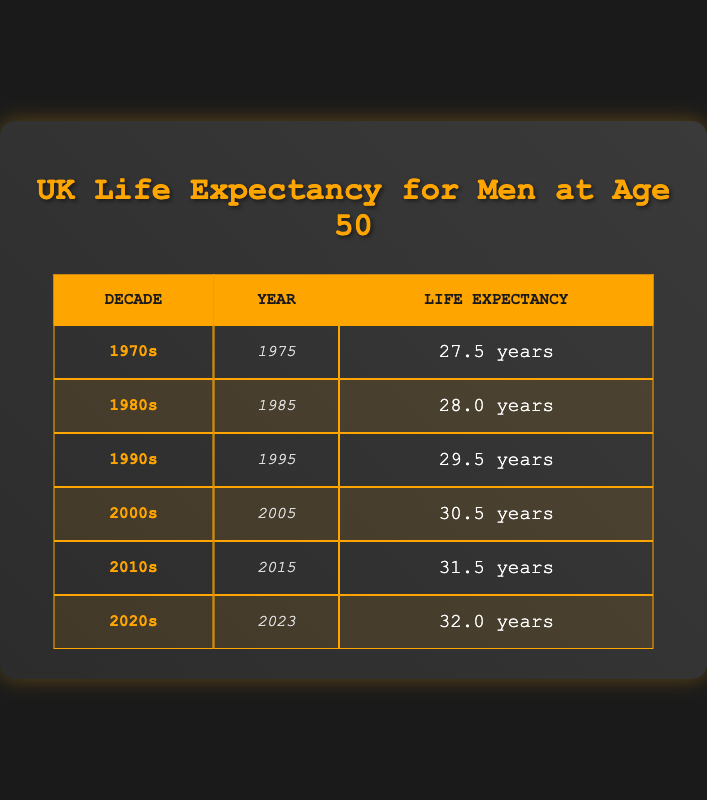What was the life expectancy at age 50 for men in the 1980s? The table indicates that in the 1980s, the life expectancy for men at age 50 was listed alongside the year 1985. This value is explicitly provided as 28.0 years.
Answer: 28.0 years Which decade had the lowest life expectancy for men at age 50? By reviewing the life expectancy values provided in the table, the 1970s show the lowest figure at 27.5 years, compared to other decades listed.
Answer: 1970s What is the difference in life expectancy at age 50 for men between the 1990s and the 2000s? To find the difference, we subtract the life expectancy of the 1990s (29.5 years) from the 2000s (30.5 years). The calculation shows a difference of 1.0 years (30.5 - 29.5 = 1.0).
Answer: 1.0 years Is the life expectancy for men at age 50 in the 2020s higher than 31 years? The table shows that life expectancy in the 2020s is 32.0 years, which is indeed higher than 31 years, therefore the statement is true.
Answer: Yes What is the average life expectancy for men at age 50 across all decades listed? The life expectancy values are 27.5, 28.0, 29.5, 30.5, 31.5, and 32.0 years. First, sum these values: (27.5 + 28.0 + 29.5 + 30.5 + 31.5 + 32.0) = 179.0. Now, divide by the number of decades (6): 179.0 / 6 = 29.8333, rounded to one decimal place is 29.8.
Answer: 29.8 years How much has the life expectancy at age 50 for men increased from the 1970s to the 2020s? The life expectancy in the 1970s is 27.5 years and in the 2020s is 32.0 years. To find the increase, subtract 27.5 from 32.0, resulting in an increase of 4.5 years (32.0 - 27.5 = 4.5).
Answer: 4.5 years 